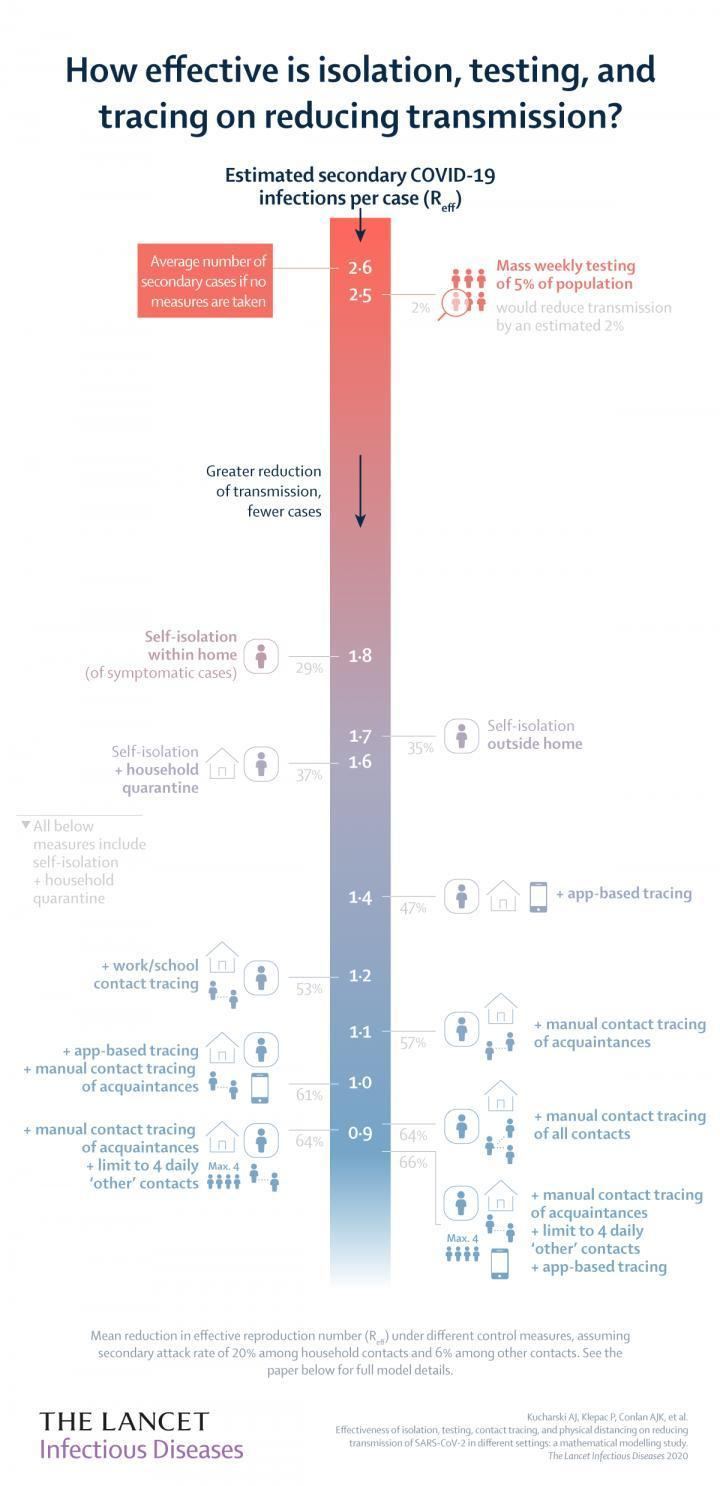What is the estimated secondary COVID-19 infections per case if self-isolation is done outside the home?
Answer the question with a short phrase. 1.7 What is the estimated percentage reduction in the transmission of COVID-19 if self isolation along with household quarantine is done? 37% What is the estimated secondary COVID-19 infections per case if self isolation is done within home for symptomatic cases? 1.8 What is the estimated secondary COVID-19 infections per case if self isolation along with household quarantine is done for symptomatic cases? 1.6 What is the estimated percentage reduction in the transmission of COVID-19 if self-isolation is done outside the home? 35% 